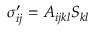Convert formula to latex. <formula><loc_0><loc_0><loc_500><loc_500>\begin{array} { r } { \sigma _ { i j } ^ { \prime } = A _ { i j k l } S _ { k l } } \end{array}</formula> 